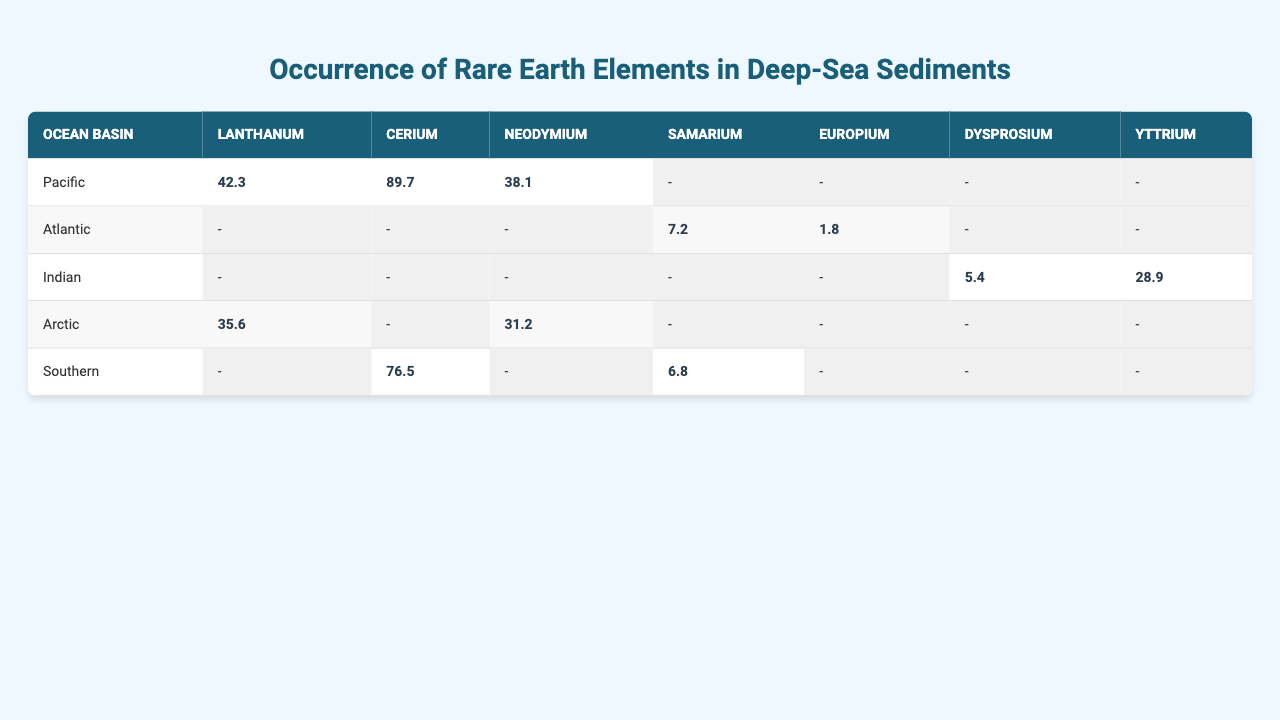What is the concentration of Lanthanum in the Pacific Ocean basin? The table shows that the concentration of Lanthanum in the Pacific basin is listed as 42.3.
Answer: 42.3 Which ocean basin has the highest concentration of Cerium? The Southern Ocean basin has the highest concentration of Cerium at 76.5, which can be verified by comparing the values across all basins in the table.
Answer: Southern Is there any occurrence of Europium in the Indian Ocean basin? The table indicates that there is no entry for Europium in the Indian basin, and thus the answer is no.
Answer: No What is the sum of Neodymium concentrations in the Arctic and Southern ocean basins? The concentration of Neodymium in the Arctic is 31.2 and in the Southern basin is 0 (not present). The sum is therefore 31.2 + 0 = 31.2.
Answer: 31.2 Which rare earth element has the lowest concentration in the Atlantic Ocean basin? The table shows that Europium has the lowest concentration in the Atlantic at 1.8, lower than Samarium which has 7.2.
Answer: Europium Calculate the average concentration of Dysprosium across all ocean basins. Dysprosium appears only in the Indian Ocean basin with a concentration of 5.4. Since there is only one value, the average is also 5.4.
Answer: 5.4 Does the Pacific Ocean basin have a higher concentration of Yttrium than the Atlantic Ocean basin? The Pacific Ocean basin has no reported concentration for Yttrium (not present), while the Atlantic does not have an entry for Yttrium as well, indicating both are absent. So the answer is yes, as neither has a value.
Answer: Yes What is the total concentration of Samarium in Atlantic and Southern ocean basins? The concentration of Samarium in the Atlantic is 7.2 and in the Southern basin is 6.8. The total concentration is 7.2 + 6.8 = 14.0.
Answer: 14.0 Which element has a concentration greater than 40 in any ocean basin? Both Lanthanum in the Pacific (42.3) and Cerium in the Pacific (89.7) exceed 40, as evident in the table.
Answer: Lanthanum and Cerium Identify the ocean basin with the highest total concentration of rare earth elements, considering only those listed. Totaling the available concentrations shows that the Pacific basin has 42.3 (Lanthanum) + 89.7 (Cerium) + 38.1 (Neodymium) = 170.1, which is the highest total among the listed basins.
Answer: Pacific 